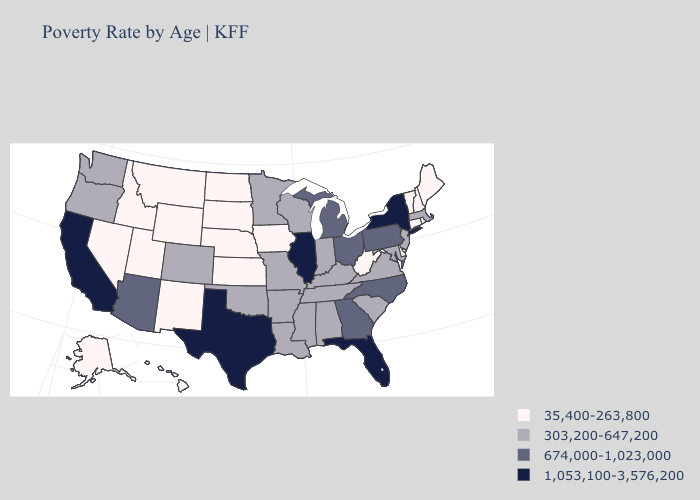Does Mississippi have the lowest value in the USA?
Concise answer only. No. What is the lowest value in the South?
Be succinct. 35,400-263,800. What is the lowest value in states that border Oregon?
Write a very short answer. 35,400-263,800. Name the states that have a value in the range 674,000-1,023,000?
Give a very brief answer. Arizona, Georgia, Michigan, North Carolina, Ohio, Pennsylvania. What is the value of Vermont?
Quick response, please. 35,400-263,800. What is the value of Connecticut?
Answer briefly. 35,400-263,800. Is the legend a continuous bar?
Short answer required. No. What is the lowest value in states that border Utah?
Give a very brief answer. 35,400-263,800. What is the value of New York?
Be succinct. 1,053,100-3,576,200. Does Delaware have the lowest value in the USA?
Write a very short answer. Yes. What is the value of Iowa?
Write a very short answer. 35,400-263,800. What is the lowest value in states that border Mississippi?
Quick response, please. 303,200-647,200. What is the highest value in the USA?
Answer briefly. 1,053,100-3,576,200. What is the highest value in states that border Rhode Island?
Short answer required. 303,200-647,200. Does New Hampshire have the highest value in the USA?
Concise answer only. No. 